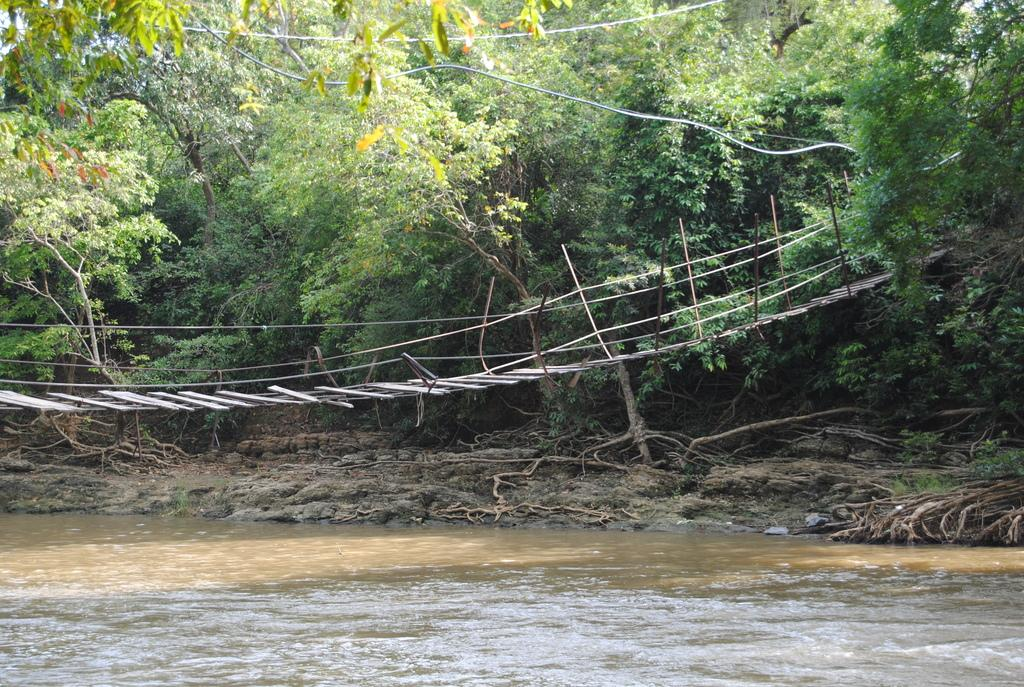What is the primary element visible in the image? There is water in the image. What structure is present over the water? There is a bridge over the water in the image. What can be seen in the distance in the image? Trees are visible in the background of the image. What type of kettle is hanging from the trees in the image? There is no kettle present in the image; it features water, a bridge, and trees in the background. Can you see any stars in the image? The image does not show any stars; it is focused on the water, bridge, and trees. 